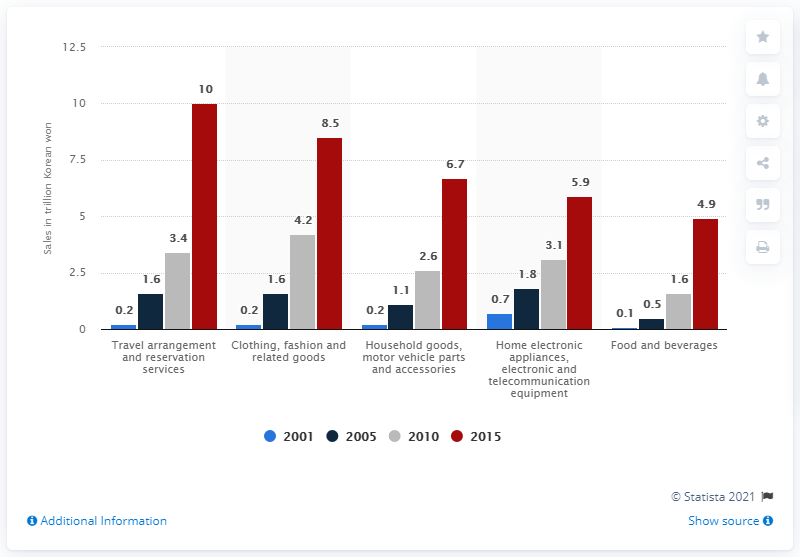Highlight a few significant elements in this photo. Online shoppers in Korea spent an estimated 10 trillion Korean won on travel purchases in 2015. 